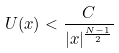<formula> <loc_0><loc_0><loc_500><loc_500>U ( x ) < \frac { C } { | x | ^ { \frac { N - 1 } { 2 } } }</formula> 